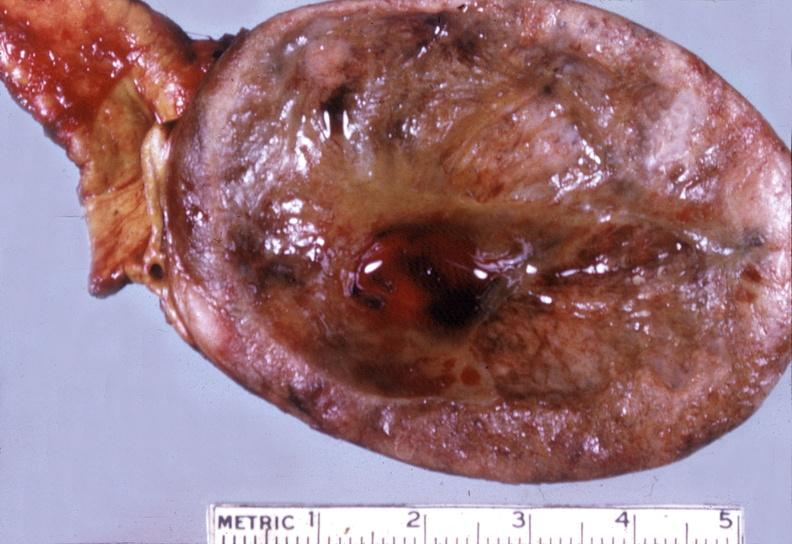s endocrine present?
Answer the question using a single word or phrase. Yes 